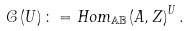Convert formula to latex. <formula><loc_0><loc_0><loc_500><loc_500>\mathcal { C } \left ( U \right ) \colon = H o m _ { \mathbb { A B } } \left ( A , Z \right ) ^ { U } .</formula> 